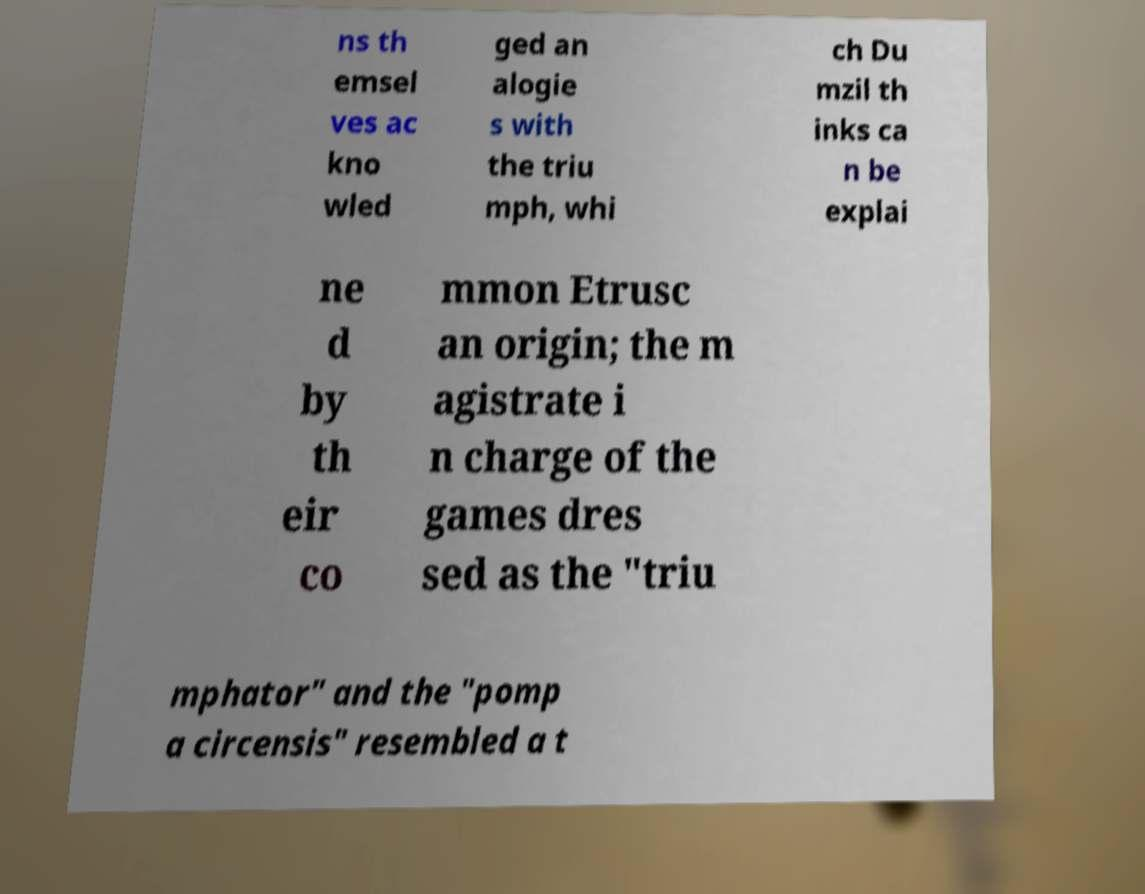Please identify and transcribe the text found in this image. ns th emsel ves ac kno wled ged an alogie s with the triu mph, whi ch Du mzil th inks ca n be explai ne d by th eir co mmon Etrusc an origin; the m agistrate i n charge of the games dres sed as the "triu mphator" and the "pomp a circensis" resembled a t 